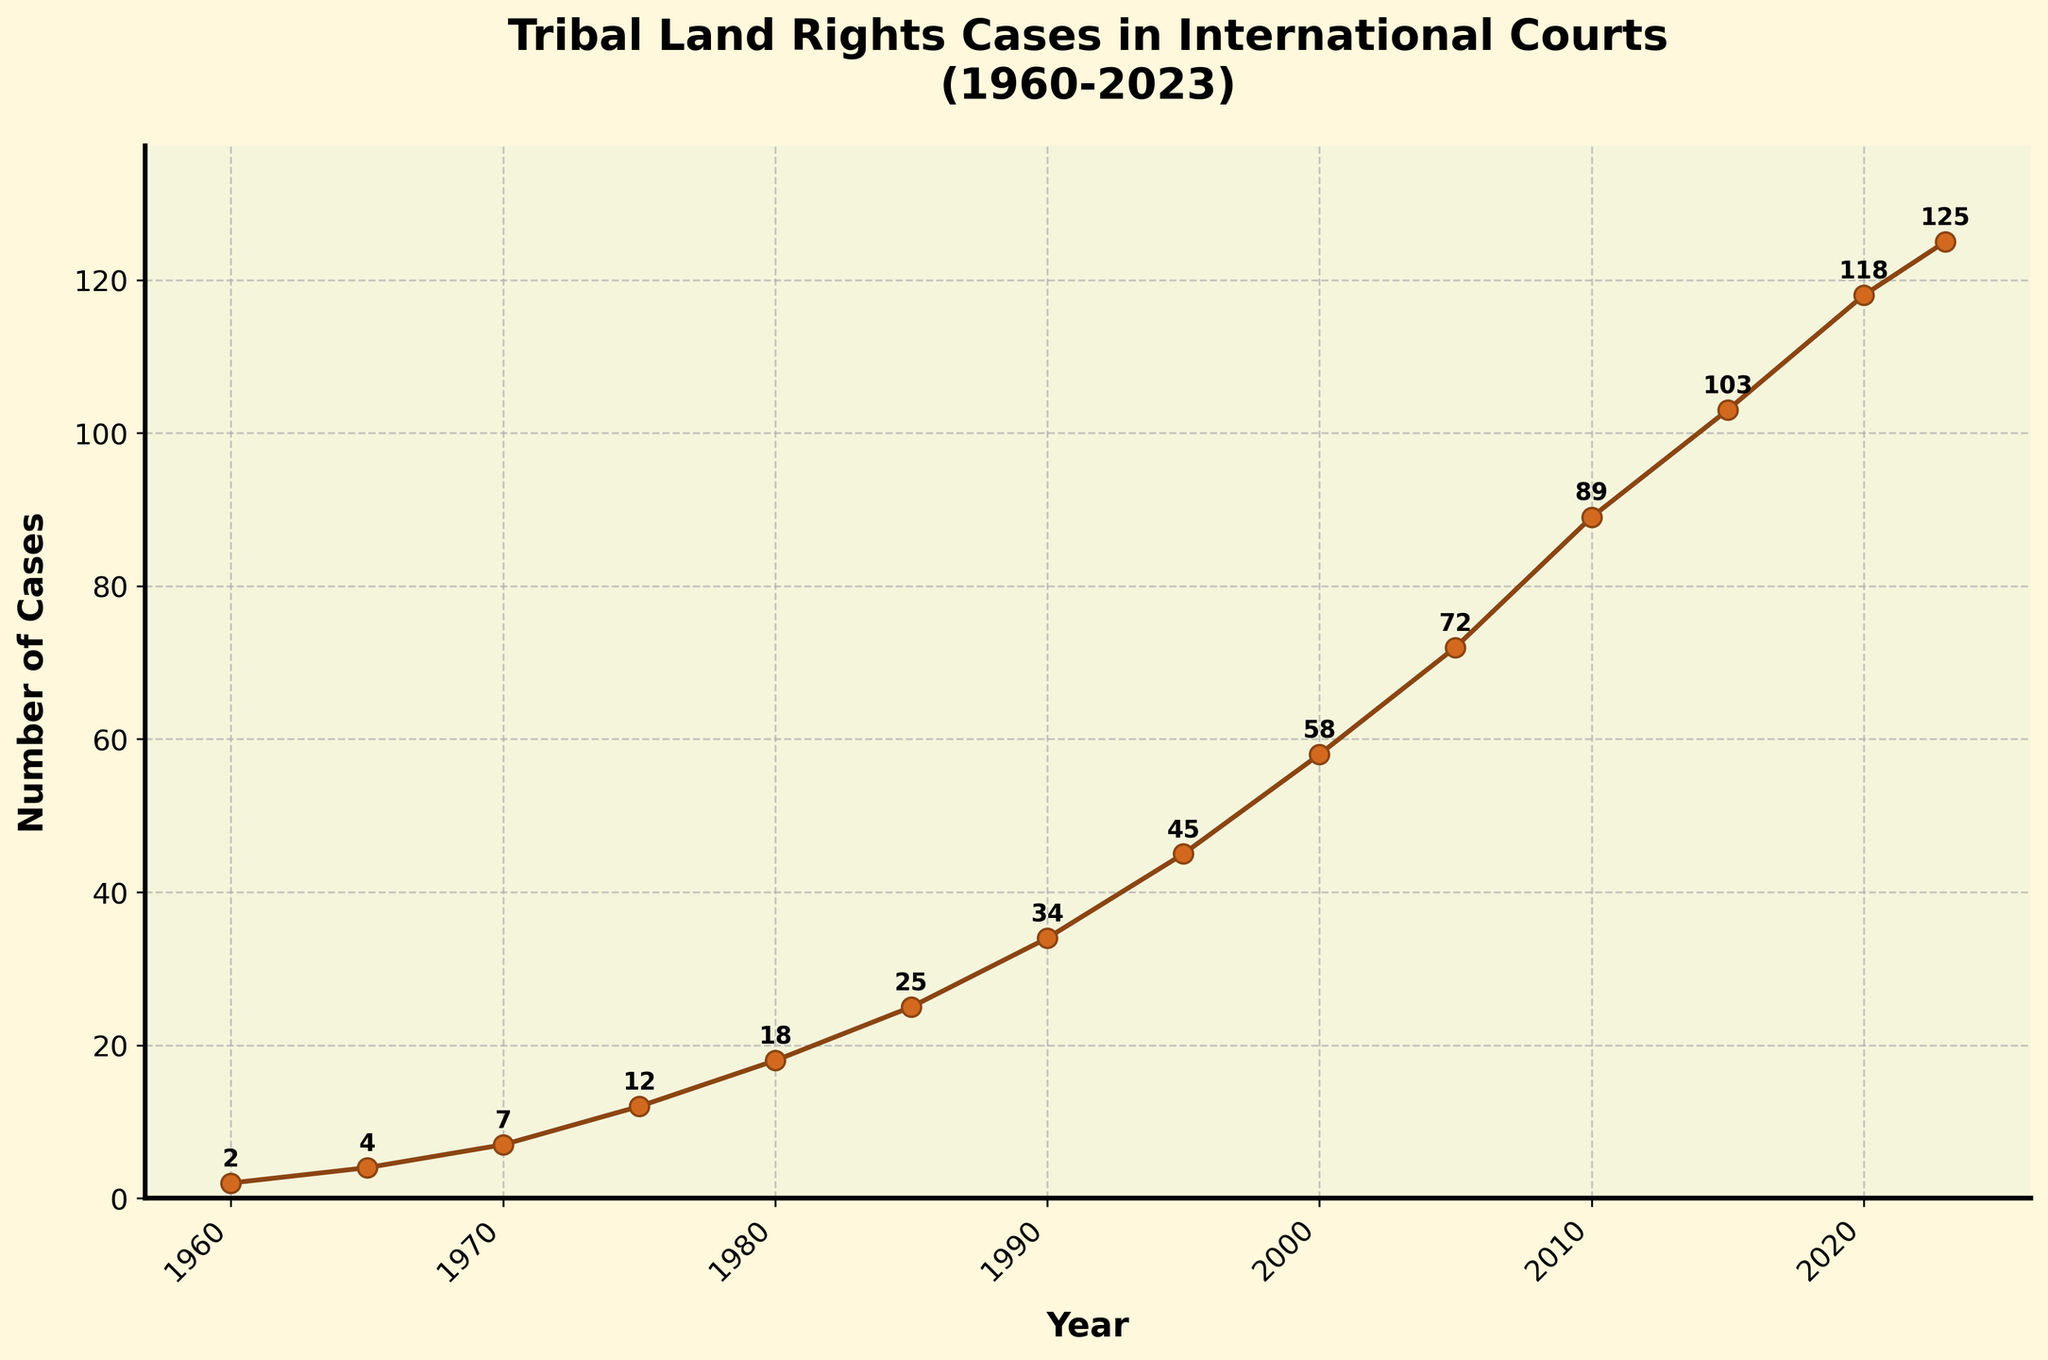what is the number of tribal land rights cases reported in 2000? Identify the value corresponding to the year 2000 from the plot, which in this case is 58.
Answer: 58 By how many cases did the number of tribal land rights cases increase from 1960 to 1980? Subtract the number of cases in 1960 (2 cases) from the number in 1980 (18 cases). 18 - 2 = 16
Answer: 16 What is the average number of cases reported per year between 2000 and 2010? The sum of cases from 2000 to 2010: 58 + 72 + 89 = 219. There are 3 years included (2000, 2005, 2010), dividing the total by 3, 219 / 3 = 73.
Answer: 73 What's the total number of tribal land rights cases heard by international courts from 1960 to 2023? Sum all the case numbers: 2 + 4 + 7 + 12 + 18 + 25 + 34 + 45 + 58 + 72 + 89 + 103 + 118 + 125 = 712.
Answer: 712 What was the rate of change in the number of cases from 1990 to 2000? Subtract the number of cases in 1990 (34 cases) from the number in 2000 (58 cases) and divide by the number in 1990. 
(58 - 34) / 34 = 24 / 34 ≈ 0.71 or 71%.
Answer: 71% How does the number of cases heard in 2010 compare with that in 1985? Subtract the number of cases in 1985 (25) from the number in 2010 (89). 
89 - 25 = 64. There were 64 more cases in 2010 compared to 1985.
Answer: 64 Name the two years between which there was the largest single-period increase in tribal land rights cases and state the increase. Identify the period with the highest increase by comparing the differences between consecutive years:
- 1960-1965: 2
- 1965-1970: 3
- 1970-1975: 5
- 1975-1980: 6
- 1980-1985: 7
- 1985-1990: 9
- 1990-1995: 11
- 1995-2000: 13
- 2000-2005: 14
- 2005-2010: 17
- 2010-2015: 14
- 2015-2020: 15
- 2020-2023: 7
The largest increase was from 2005 to 2010 with an increase of 17 cases.
Answer: 2005-2010, 17 